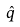<formula> <loc_0><loc_0><loc_500><loc_500>\hat { q }</formula> 